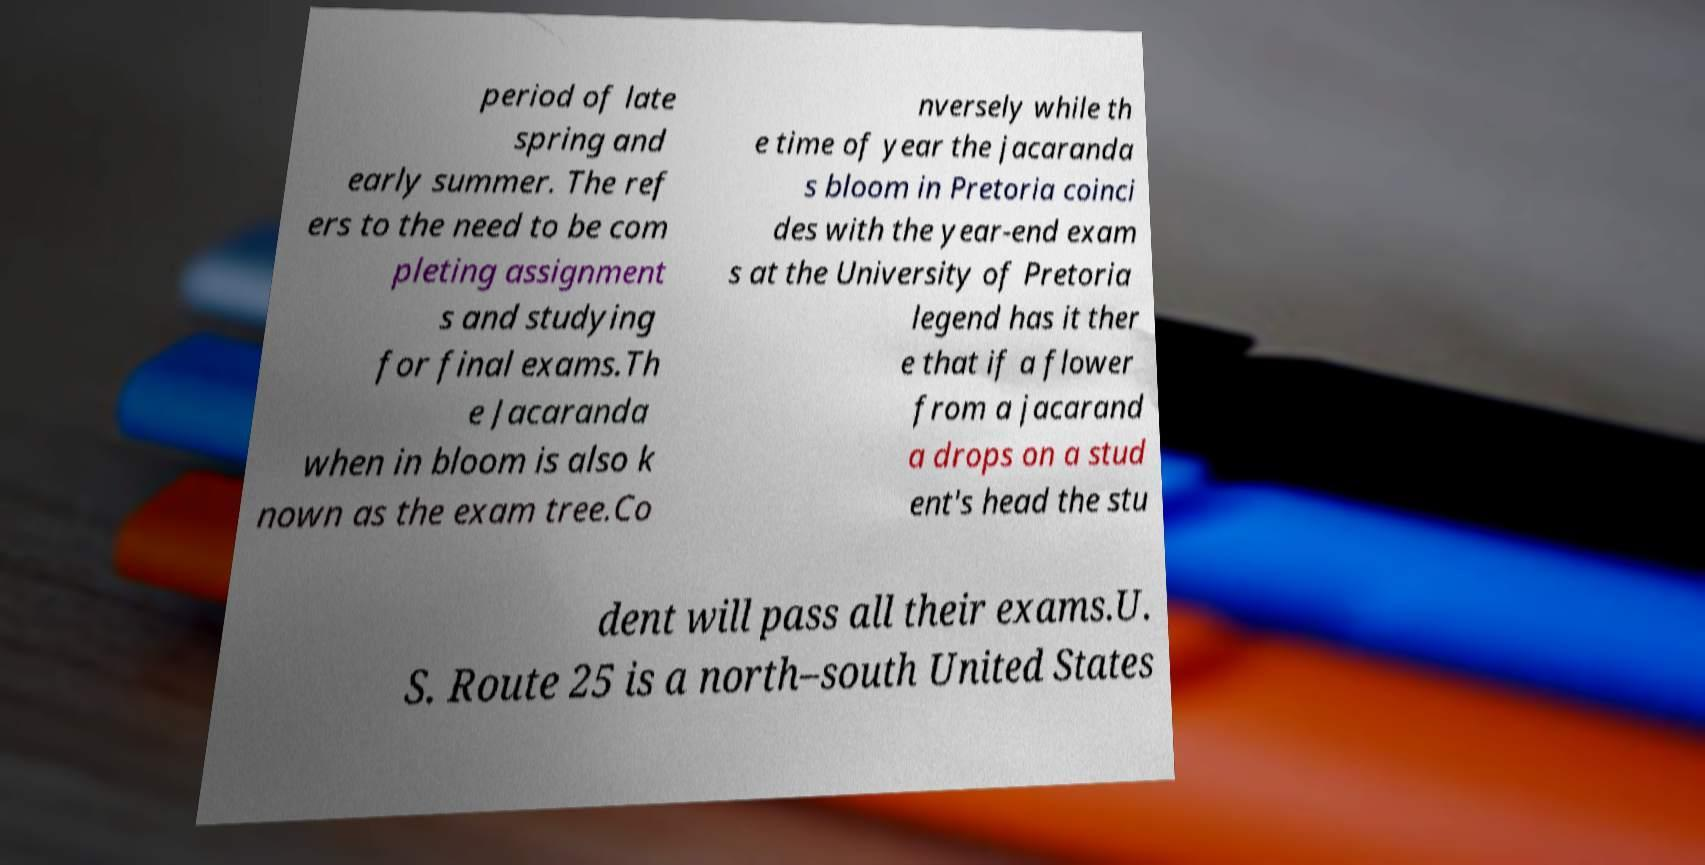Please identify and transcribe the text found in this image. period of late spring and early summer. The ref ers to the need to be com pleting assignment s and studying for final exams.Th e Jacaranda when in bloom is also k nown as the exam tree.Co nversely while th e time of year the jacaranda s bloom in Pretoria coinci des with the year-end exam s at the University of Pretoria legend has it ther e that if a flower from a jacarand a drops on a stud ent's head the stu dent will pass all their exams.U. S. Route 25 is a north–south United States 